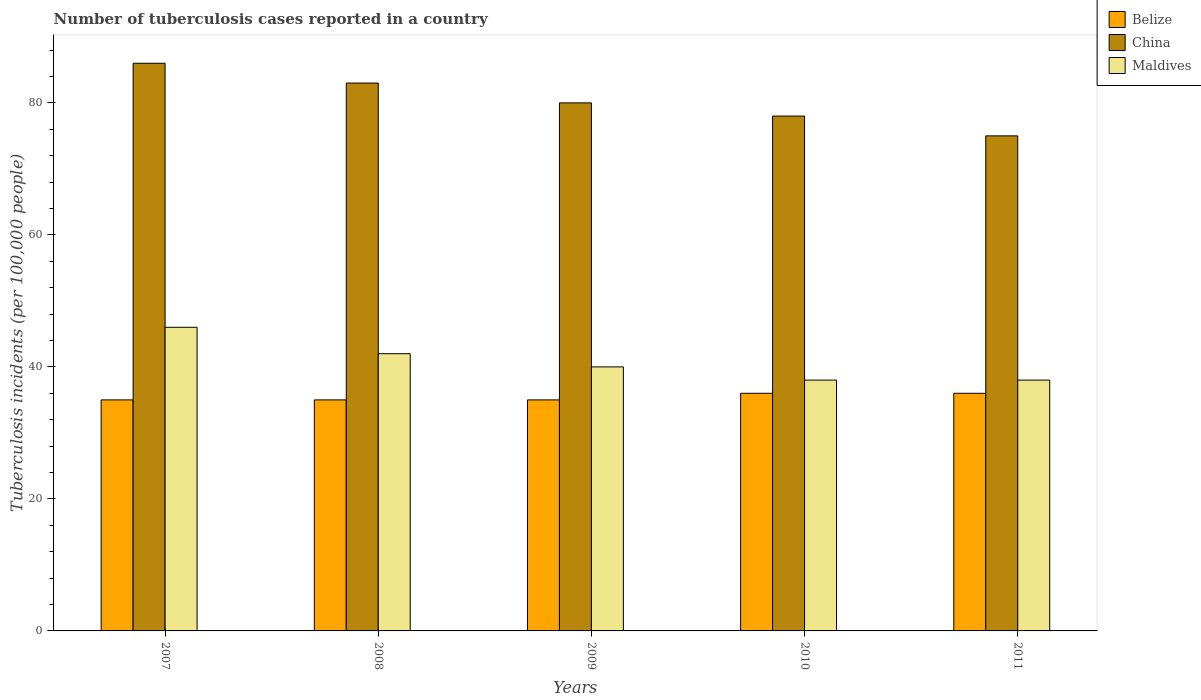Are the number of bars on each tick of the X-axis equal?
Your response must be concise. Yes. How many bars are there on the 1st tick from the left?
Give a very brief answer. 3. What is the label of the 2nd group of bars from the left?
Provide a short and direct response. 2008. What is the number of tuberculosis cases reported in in Belize in 2010?
Your response must be concise. 36. Across all years, what is the maximum number of tuberculosis cases reported in in Belize?
Provide a short and direct response. 36. Across all years, what is the minimum number of tuberculosis cases reported in in Belize?
Offer a terse response. 35. What is the total number of tuberculosis cases reported in in Belize in the graph?
Give a very brief answer. 177. What is the difference between the number of tuberculosis cases reported in in China in 2008 and that in 2011?
Make the answer very short. 8. What is the difference between the number of tuberculosis cases reported in in Maldives in 2010 and the number of tuberculosis cases reported in in Belize in 2009?
Your answer should be very brief. 3. What is the average number of tuberculosis cases reported in in Maldives per year?
Your answer should be compact. 40.8. In the year 2011, what is the difference between the number of tuberculosis cases reported in in Maldives and number of tuberculosis cases reported in in China?
Provide a short and direct response. -37. In how many years, is the number of tuberculosis cases reported in in Belize greater than 76?
Your answer should be compact. 0. What is the ratio of the number of tuberculosis cases reported in in Belize in 2008 to that in 2011?
Make the answer very short. 0.97. Is the number of tuberculosis cases reported in in China in 2007 less than that in 2009?
Your answer should be compact. No. What is the difference between the highest and the second highest number of tuberculosis cases reported in in Maldives?
Offer a terse response. 4. What is the difference between the highest and the lowest number of tuberculosis cases reported in in China?
Give a very brief answer. 11. What does the 1st bar from the left in 2010 represents?
Offer a very short reply. Belize. What does the 3rd bar from the right in 2010 represents?
Provide a short and direct response. Belize. Are all the bars in the graph horizontal?
Ensure brevity in your answer.  No. Does the graph contain any zero values?
Your answer should be compact. No. How many legend labels are there?
Make the answer very short. 3. How are the legend labels stacked?
Ensure brevity in your answer.  Vertical. What is the title of the graph?
Provide a succinct answer. Number of tuberculosis cases reported in a country. Does "Kenya" appear as one of the legend labels in the graph?
Offer a terse response. No. What is the label or title of the X-axis?
Provide a succinct answer. Years. What is the label or title of the Y-axis?
Your answer should be very brief. Tuberculosis incidents (per 100,0 people). What is the Tuberculosis incidents (per 100,000 people) of China in 2007?
Your answer should be compact. 86. What is the Tuberculosis incidents (per 100,000 people) in Maldives in 2007?
Your answer should be very brief. 46. What is the Tuberculosis incidents (per 100,000 people) in Belize in 2008?
Offer a very short reply. 35. What is the Tuberculosis incidents (per 100,000 people) in China in 2008?
Your answer should be compact. 83. What is the Tuberculosis incidents (per 100,000 people) in Maldives in 2008?
Provide a succinct answer. 42. What is the Tuberculosis incidents (per 100,000 people) of China in 2009?
Offer a terse response. 80. What is the Tuberculosis incidents (per 100,000 people) of Belize in 2010?
Your answer should be compact. 36. What is the Tuberculosis incidents (per 100,000 people) in China in 2010?
Offer a terse response. 78. What is the Tuberculosis incidents (per 100,000 people) in Belize in 2011?
Keep it short and to the point. 36. What is the Tuberculosis incidents (per 100,000 people) of China in 2011?
Keep it short and to the point. 75. Across all years, what is the maximum Tuberculosis incidents (per 100,000 people) of Belize?
Keep it short and to the point. 36. Across all years, what is the minimum Tuberculosis incidents (per 100,000 people) in Maldives?
Ensure brevity in your answer.  38. What is the total Tuberculosis incidents (per 100,000 people) in Belize in the graph?
Offer a very short reply. 177. What is the total Tuberculosis incidents (per 100,000 people) of China in the graph?
Ensure brevity in your answer.  402. What is the total Tuberculosis incidents (per 100,000 people) in Maldives in the graph?
Provide a short and direct response. 204. What is the difference between the Tuberculosis incidents (per 100,000 people) in Belize in 2007 and that in 2008?
Give a very brief answer. 0. What is the difference between the Tuberculosis incidents (per 100,000 people) of Maldives in 2007 and that in 2008?
Your response must be concise. 4. What is the difference between the Tuberculosis incidents (per 100,000 people) of Belize in 2007 and that in 2009?
Your response must be concise. 0. What is the difference between the Tuberculosis incidents (per 100,000 people) in Belize in 2007 and that in 2010?
Provide a short and direct response. -1. What is the difference between the Tuberculosis incidents (per 100,000 people) in Maldives in 2007 and that in 2010?
Give a very brief answer. 8. What is the difference between the Tuberculosis incidents (per 100,000 people) in Belize in 2008 and that in 2009?
Provide a short and direct response. 0. What is the difference between the Tuberculosis incidents (per 100,000 people) in China in 2008 and that in 2009?
Provide a succinct answer. 3. What is the difference between the Tuberculosis incidents (per 100,000 people) of China in 2008 and that in 2011?
Make the answer very short. 8. What is the difference between the Tuberculosis incidents (per 100,000 people) in China in 2009 and that in 2010?
Your answer should be very brief. 2. What is the difference between the Tuberculosis incidents (per 100,000 people) of China in 2010 and that in 2011?
Provide a succinct answer. 3. What is the difference between the Tuberculosis incidents (per 100,000 people) in Belize in 2007 and the Tuberculosis incidents (per 100,000 people) in China in 2008?
Provide a short and direct response. -48. What is the difference between the Tuberculosis incidents (per 100,000 people) in China in 2007 and the Tuberculosis incidents (per 100,000 people) in Maldives in 2008?
Your answer should be compact. 44. What is the difference between the Tuberculosis incidents (per 100,000 people) in Belize in 2007 and the Tuberculosis incidents (per 100,000 people) in China in 2009?
Offer a very short reply. -45. What is the difference between the Tuberculosis incidents (per 100,000 people) of Belize in 2007 and the Tuberculosis incidents (per 100,000 people) of Maldives in 2009?
Provide a succinct answer. -5. What is the difference between the Tuberculosis incidents (per 100,000 people) in Belize in 2007 and the Tuberculosis incidents (per 100,000 people) in China in 2010?
Provide a short and direct response. -43. What is the difference between the Tuberculosis incidents (per 100,000 people) in Belize in 2007 and the Tuberculosis incidents (per 100,000 people) in Maldives in 2010?
Keep it short and to the point. -3. What is the difference between the Tuberculosis incidents (per 100,000 people) in China in 2007 and the Tuberculosis incidents (per 100,000 people) in Maldives in 2010?
Make the answer very short. 48. What is the difference between the Tuberculosis incidents (per 100,000 people) of Belize in 2007 and the Tuberculosis incidents (per 100,000 people) of China in 2011?
Your response must be concise. -40. What is the difference between the Tuberculosis incidents (per 100,000 people) in Belize in 2008 and the Tuberculosis incidents (per 100,000 people) in China in 2009?
Make the answer very short. -45. What is the difference between the Tuberculosis incidents (per 100,000 people) of China in 2008 and the Tuberculosis incidents (per 100,000 people) of Maldives in 2009?
Provide a short and direct response. 43. What is the difference between the Tuberculosis incidents (per 100,000 people) of Belize in 2008 and the Tuberculosis incidents (per 100,000 people) of China in 2010?
Offer a terse response. -43. What is the difference between the Tuberculosis incidents (per 100,000 people) in Belize in 2008 and the Tuberculosis incidents (per 100,000 people) in Maldives in 2010?
Your response must be concise. -3. What is the difference between the Tuberculosis incidents (per 100,000 people) in China in 2008 and the Tuberculosis incidents (per 100,000 people) in Maldives in 2010?
Provide a succinct answer. 45. What is the difference between the Tuberculosis incidents (per 100,000 people) in Belize in 2008 and the Tuberculosis incidents (per 100,000 people) in China in 2011?
Your answer should be compact. -40. What is the difference between the Tuberculosis incidents (per 100,000 people) in Belize in 2009 and the Tuberculosis incidents (per 100,000 people) in China in 2010?
Your answer should be compact. -43. What is the difference between the Tuberculosis incidents (per 100,000 people) in Belize in 2009 and the Tuberculosis incidents (per 100,000 people) in Maldives in 2011?
Offer a terse response. -3. What is the difference between the Tuberculosis incidents (per 100,000 people) of Belize in 2010 and the Tuberculosis incidents (per 100,000 people) of China in 2011?
Offer a terse response. -39. What is the difference between the Tuberculosis incidents (per 100,000 people) of Belize in 2010 and the Tuberculosis incidents (per 100,000 people) of Maldives in 2011?
Provide a short and direct response. -2. What is the difference between the Tuberculosis incidents (per 100,000 people) in China in 2010 and the Tuberculosis incidents (per 100,000 people) in Maldives in 2011?
Your response must be concise. 40. What is the average Tuberculosis incidents (per 100,000 people) in Belize per year?
Offer a terse response. 35.4. What is the average Tuberculosis incidents (per 100,000 people) in China per year?
Provide a succinct answer. 80.4. What is the average Tuberculosis incidents (per 100,000 people) in Maldives per year?
Your answer should be compact. 40.8. In the year 2007, what is the difference between the Tuberculosis incidents (per 100,000 people) of Belize and Tuberculosis incidents (per 100,000 people) of China?
Your answer should be very brief. -51. In the year 2008, what is the difference between the Tuberculosis incidents (per 100,000 people) in Belize and Tuberculosis incidents (per 100,000 people) in China?
Ensure brevity in your answer.  -48. In the year 2008, what is the difference between the Tuberculosis incidents (per 100,000 people) of Belize and Tuberculosis incidents (per 100,000 people) of Maldives?
Provide a succinct answer. -7. In the year 2009, what is the difference between the Tuberculosis incidents (per 100,000 people) of Belize and Tuberculosis incidents (per 100,000 people) of China?
Offer a very short reply. -45. In the year 2009, what is the difference between the Tuberculosis incidents (per 100,000 people) in China and Tuberculosis incidents (per 100,000 people) in Maldives?
Your answer should be very brief. 40. In the year 2010, what is the difference between the Tuberculosis incidents (per 100,000 people) of Belize and Tuberculosis incidents (per 100,000 people) of China?
Your answer should be compact. -42. In the year 2010, what is the difference between the Tuberculosis incidents (per 100,000 people) in China and Tuberculosis incidents (per 100,000 people) in Maldives?
Offer a very short reply. 40. In the year 2011, what is the difference between the Tuberculosis incidents (per 100,000 people) of Belize and Tuberculosis incidents (per 100,000 people) of China?
Your answer should be very brief. -39. In the year 2011, what is the difference between the Tuberculosis incidents (per 100,000 people) in Belize and Tuberculosis incidents (per 100,000 people) in Maldives?
Offer a terse response. -2. In the year 2011, what is the difference between the Tuberculosis incidents (per 100,000 people) of China and Tuberculosis incidents (per 100,000 people) of Maldives?
Keep it short and to the point. 37. What is the ratio of the Tuberculosis incidents (per 100,000 people) in China in 2007 to that in 2008?
Your response must be concise. 1.04. What is the ratio of the Tuberculosis incidents (per 100,000 people) in Maldives in 2007 to that in 2008?
Give a very brief answer. 1.1. What is the ratio of the Tuberculosis incidents (per 100,000 people) in China in 2007 to that in 2009?
Provide a short and direct response. 1.07. What is the ratio of the Tuberculosis incidents (per 100,000 people) in Maldives in 2007 to that in 2009?
Offer a very short reply. 1.15. What is the ratio of the Tuberculosis incidents (per 100,000 people) of Belize in 2007 to that in 2010?
Offer a terse response. 0.97. What is the ratio of the Tuberculosis incidents (per 100,000 people) in China in 2007 to that in 2010?
Your answer should be compact. 1.1. What is the ratio of the Tuberculosis incidents (per 100,000 people) of Maldives in 2007 to that in 2010?
Your answer should be very brief. 1.21. What is the ratio of the Tuberculosis incidents (per 100,000 people) in Belize in 2007 to that in 2011?
Ensure brevity in your answer.  0.97. What is the ratio of the Tuberculosis incidents (per 100,000 people) of China in 2007 to that in 2011?
Provide a short and direct response. 1.15. What is the ratio of the Tuberculosis incidents (per 100,000 people) in Maldives in 2007 to that in 2011?
Ensure brevity in your answer.  1.21. What is the ratio of the Tuberculosis incidents (per 100,000 people) of China in 2008 to that in 2009?
Offer a terse response. 1.04. What is the ratio of the Tuberculosis incidents (per 100,000 people) in Belize in 2008 to that in 2010?
Your answer should be compact. 0.97. What is the ratio of the Tuberculosis incidents (per 100,000 people) in China in 2008 to that in 2010?
Ensure brevity in your answer.  1.06. What is the ratio of the Tuberculosis incidents (per 100,000 people) of Maldives in 2008 to that in 2010?
Give a very brief answer. 1.11. What is the ratio of the Tuberculosis incidents (per 100,000 people) of Belize in 2008 to that in 2011?
Ensure brevity in your answer.  0.97. What is the ratio of the Tuberculosis incidents (per 100,000 people) in China in 2008 to that in 2011?
Your answer should be very brief. 1.11. What is the ratio of the Tuberculosis incidents (per 100,000 people) of Maldives in 2008 to that in 2011?
Ensure brevity in your answer.  1.11. What is the ratio of the Tuberculosis incidents (per 100,000 people) in Belize in 2009 to that in 2010?
Keep it short and to the point. 0.97. What is the ratio of the Tuberculosis incidents (per 100,000 people) of China in 2009 to that in 2010?
Your answer should be compact. 1.03. What is the ratio of the Tuberculosis incidents (per 100,000 people) in Maldives in 2009 to that in 2010?
Offer a very short reply. 1.05. What is the ratio of the Tuberculosis incidents (per 100,000 people) of Belize in 2009 to that in 2011?
Ensure brevity in your answer.  0.97. What is the ratio of the Tuberculosis incidents (per 100,000 people) of China in 2009 to that in 2011?
Your answer should be very brief. 1.07. What is the ratio of the Tuberculosis incidents (per 100,000 people) of Maldives in 2009 to that in 2011?
Provide a succinct answer. 1.05. What is the ratio of the Tuberculosis incidents (per 100,000 people) in China in 2010 to that in 2011?
Make the answer very short. 1.04. What is the difference between the highest and the second highest Tuberculosis incidents (per 100,000 people) in Belize?
Offer a very short reply. 0. What is the difference between the highest and the second highest Tuberculosis incidents (per 100,000 people) of Maldives?
Ensure brevity in your answer.  4. What is the difference between the highest and the lowest Tuberculosis incidents (per 100,000 people) in Maldives?
Offer a terse response. 8. 